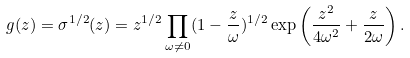Convert formula to latex. <formula><loc_0><loc_0><loc_500><loc_500>g ( z ) = \sigma ^ { 1 / 2 } ( z ) = z ^ { 1 / 2 } \prod _ { \omega \neq 0 } ( 1 - \frac { z } { \omega } ) ^ { 1 / 2 } \exp \left ( \frac { z ^ { 2 } } { 4 \omega ^ { 2 } } + \frac { z } { 2 \omega } \right ) .</formula> 